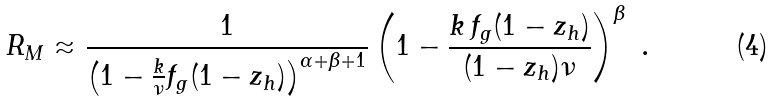Convert formula to latex. <formula><loc_0><loc_0><loc_500><loc_500>R _ { M } \approx \frac { 1 } { \left ( 1 - \frac { k } { \nu } f _ { g } ( 1 - z _ { h } ) \right ) ^ { \alpha + \beta + 1 } } \left ( 1 - \frac { k \, f _ { g } ( 1 - z _ { h } ) } { ( 1 - z _ { h } ) \nu } \right ) ^ { \beta } \ .</formula> 